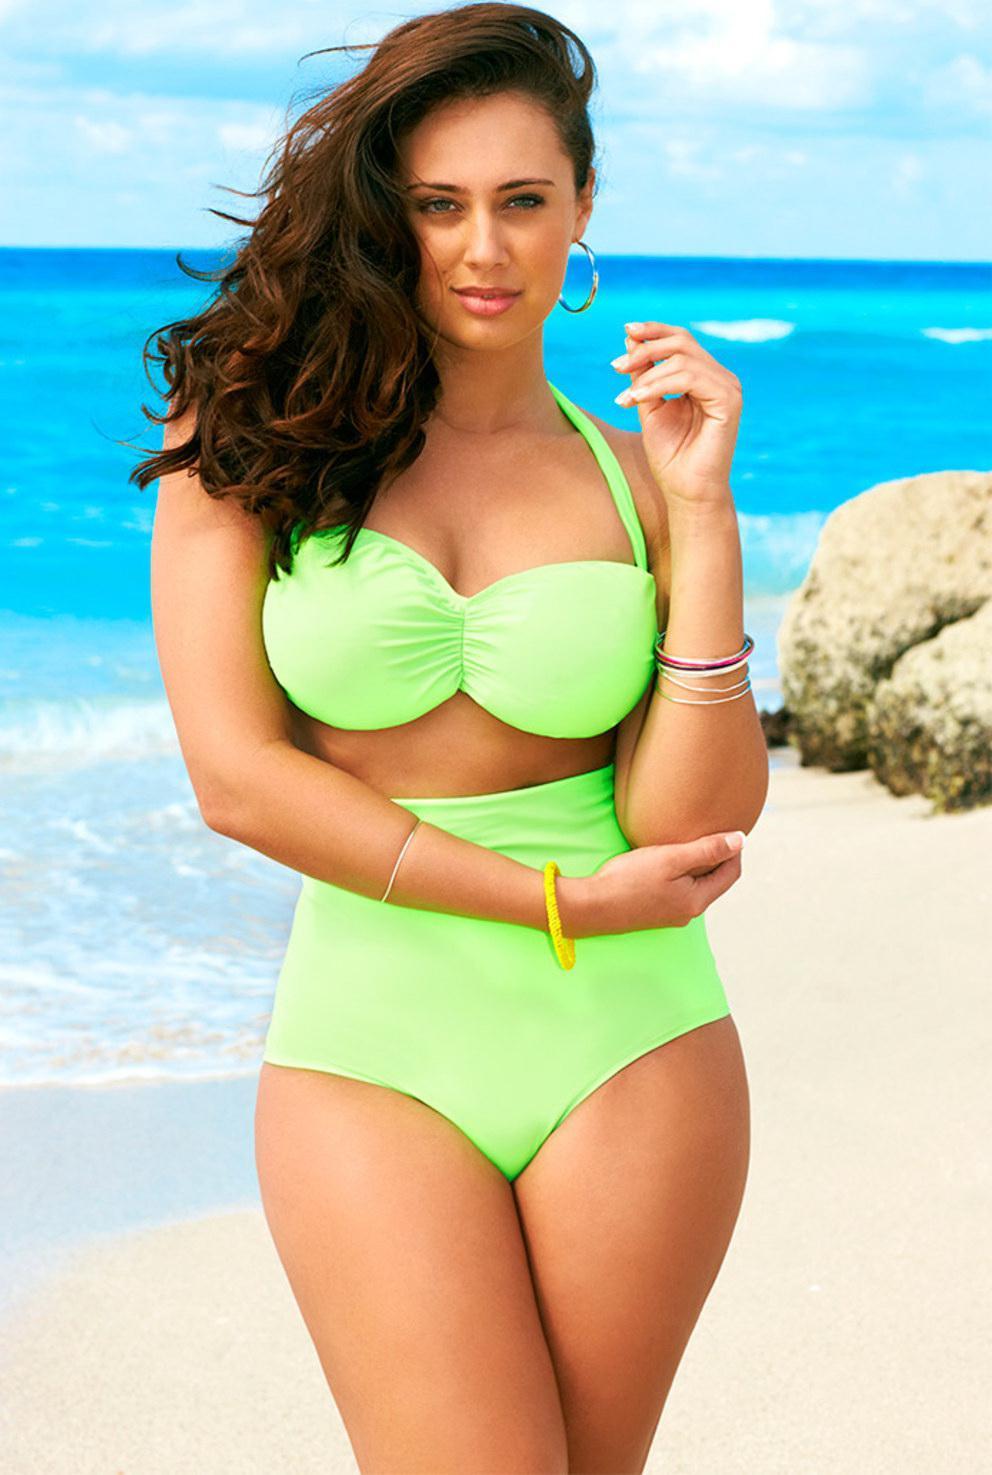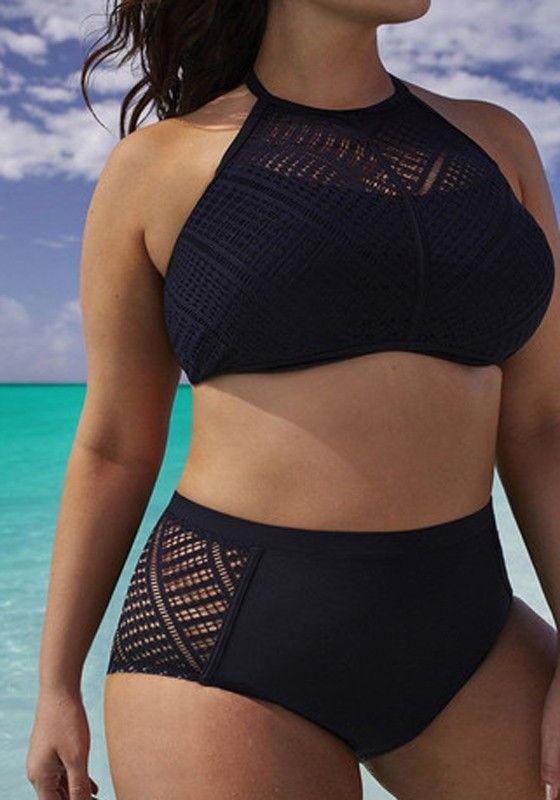The first image is the image on the left, the second image is the image on the right. For the images shown, is this caption "A woman is wearing a solid black two piece bathing suit." true? Answer yes or no. Yes. The first image is the image on the left, the second image is the image on the right. Assess this claim about the two images: "the same model is wearing a bright green bikini". Correct or not? Answer yes or no. Yes. 